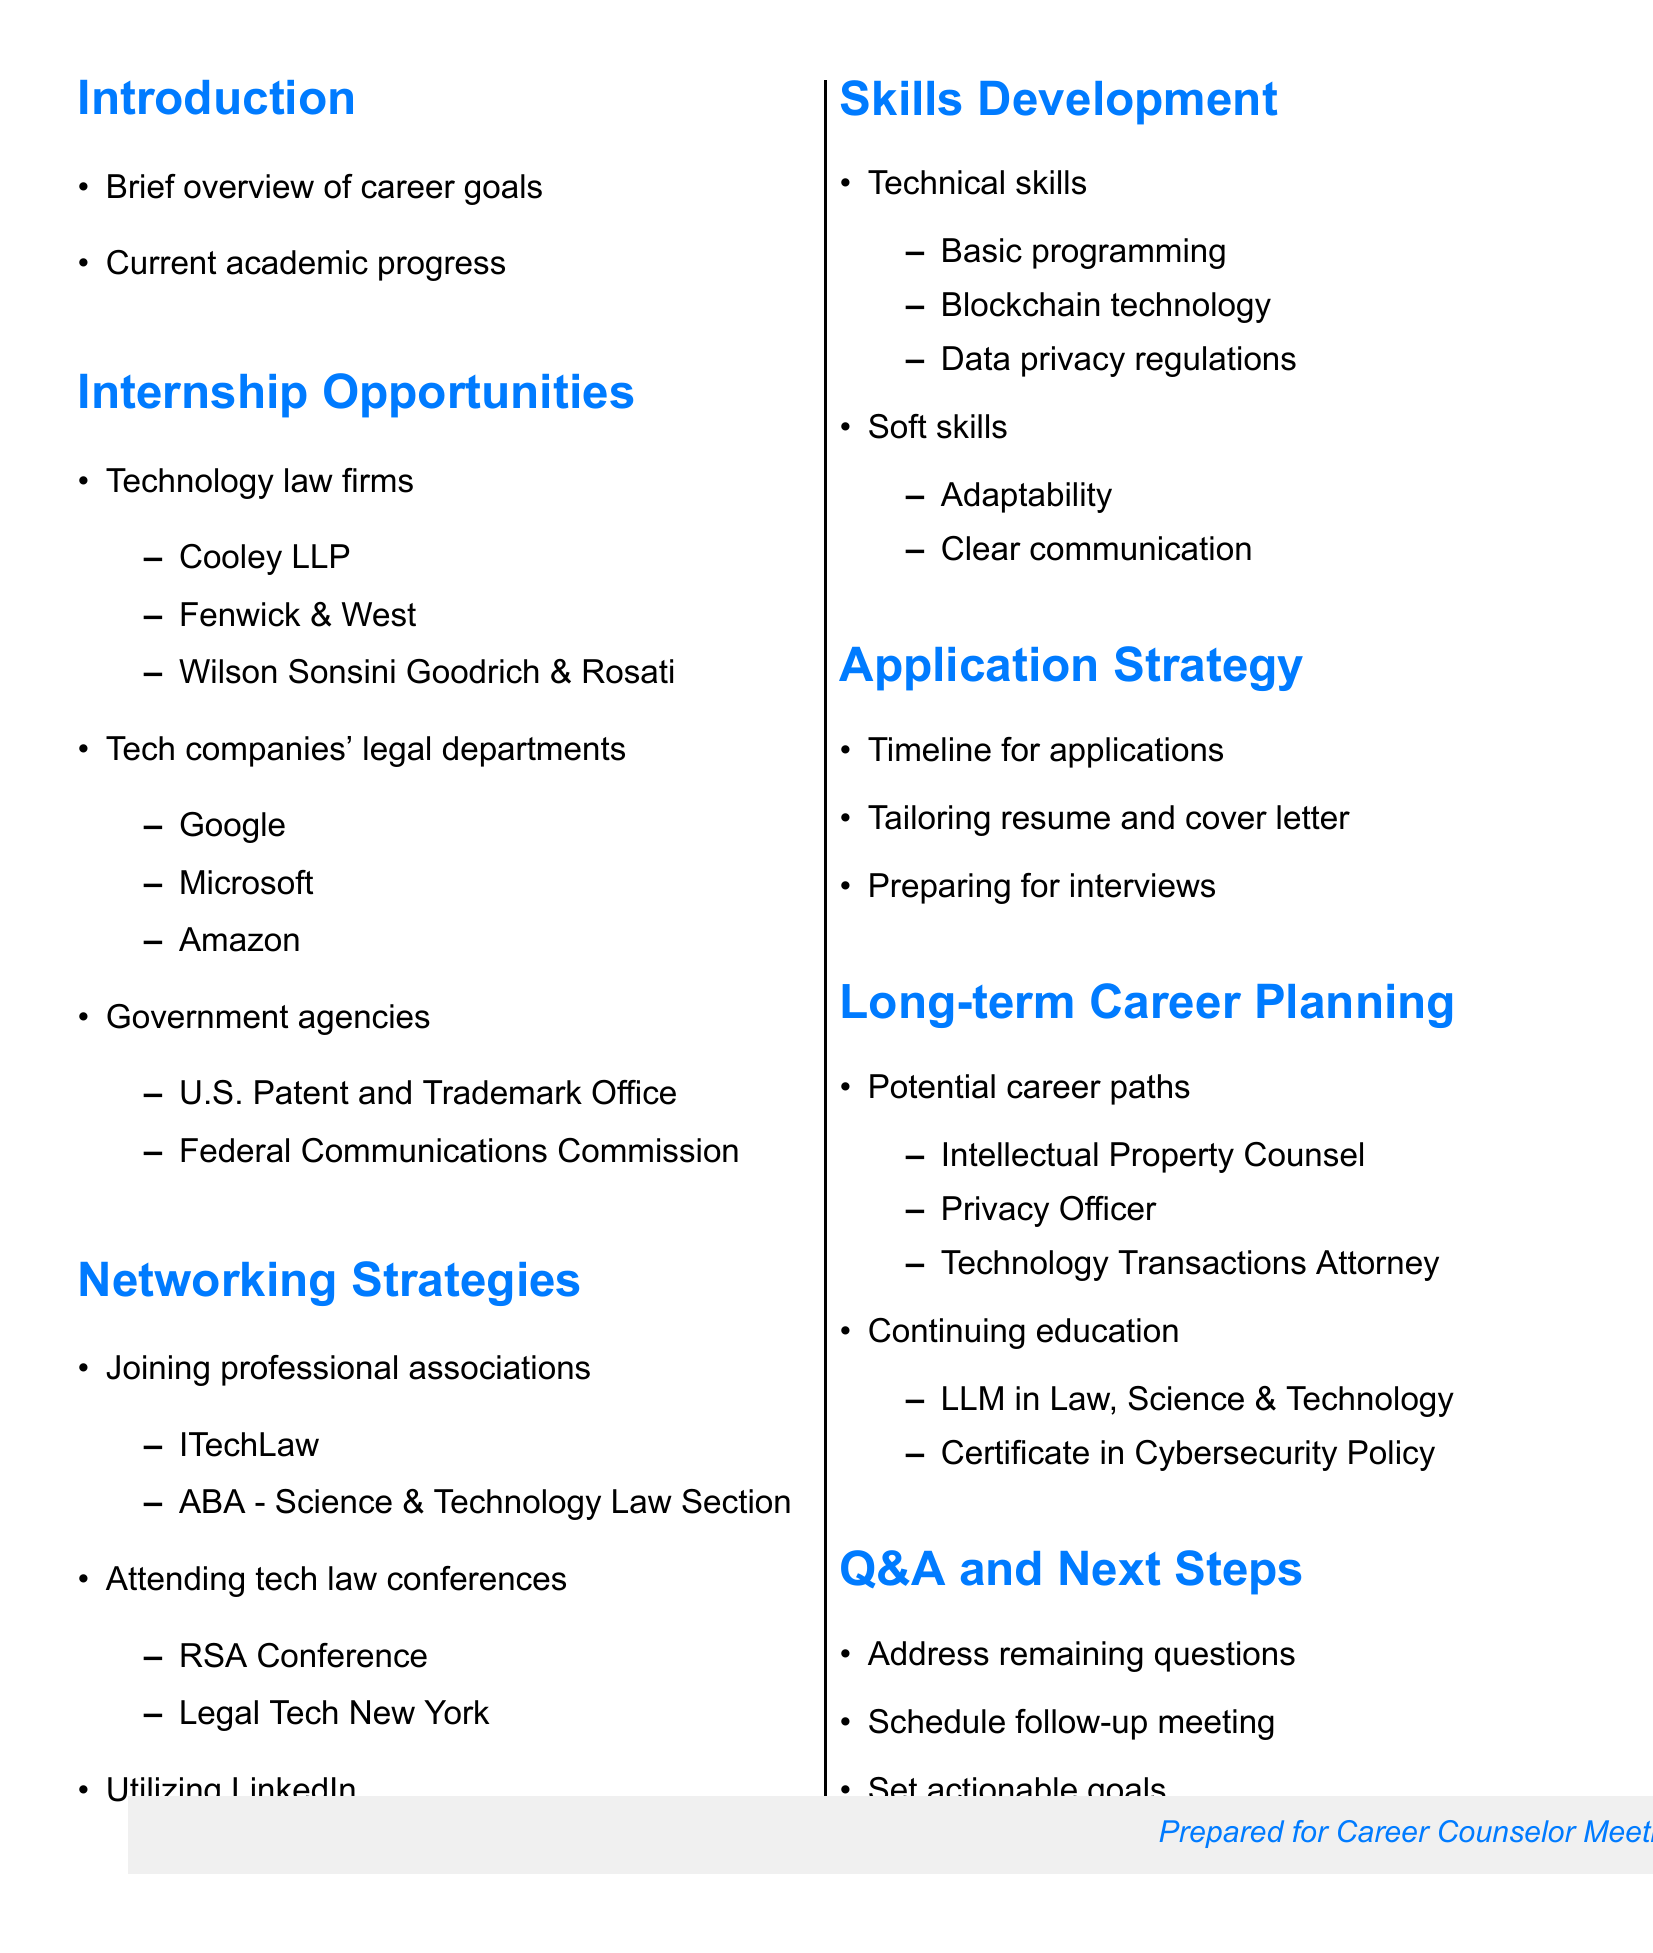what is the first section in the agenda? The first section is the Introduction, which provides an overview of career goals and academic progress.
Answer: Introduction name one technology law firm listed in the document. Cooley LLP is an example of a technology law firm mentioned in the document under the Internship Opportunities section.
Answer: Cooley LLP how many tech companies' legal departments are mentioned? There are three tech companies' legal departments listed in the document.
Answer: Three what is one professional association you can join for networking? The International Technology Law Association (ITechLaw) is one of the associations listed for networking strategies.
Answer: International Technology Law Association what skill related to technology law is highlighted in the Skills Development section? One highlighted skill is basic programming knowledge, which is essential for technology law.
Answer: Basic programming knowledge how many potential career paths in technology law are mentioned? There are three potential career paths listed in the document under Long-term Career Planning.
Answer: Three what is a key strategy for internship applications? The document suggests tailoring the resume and cover letter for technology law positions as a key application strategy.
Answer: Tailoring resume and cover letter what does the meeting agenda conclude with? The agenda concludes with a Q&A and Next Steps section, where remaining questions and actionable goals are discussed.
Answer: Q&A and Next Steps 